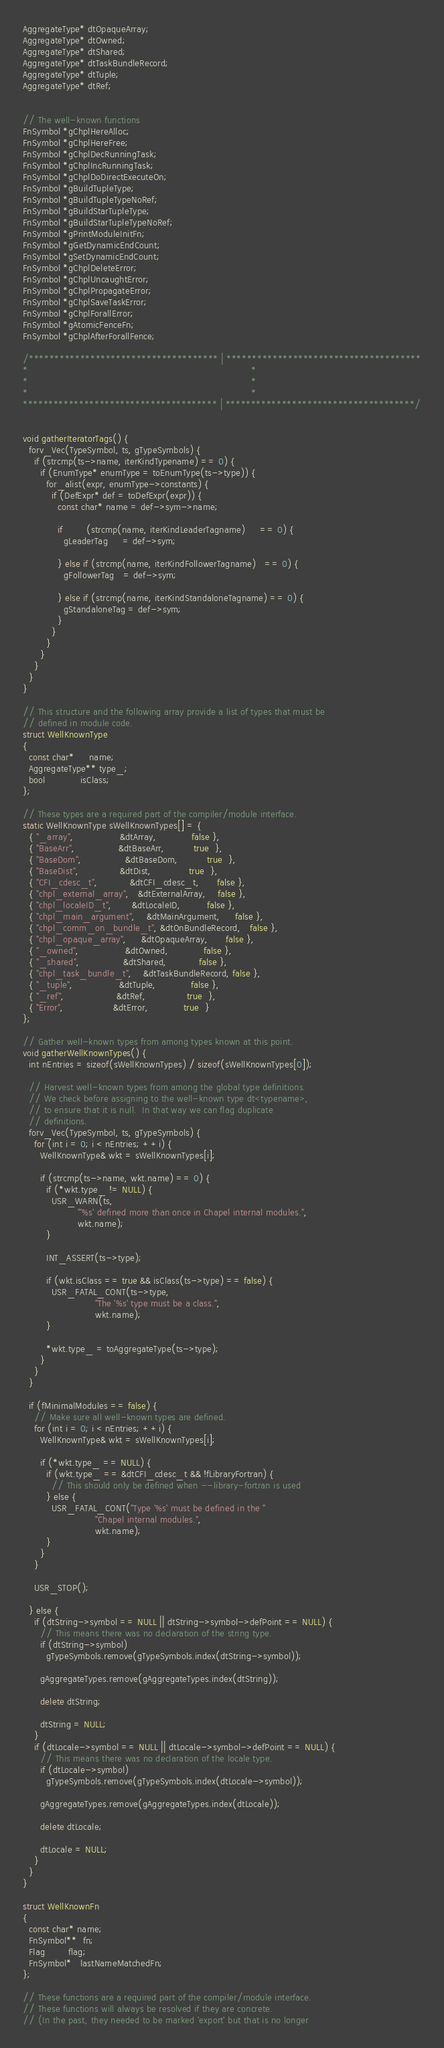<code> <loc_0><loc_0><loc_500><loc_500><_C++_>AggregateType* dtOpaqueArray;
AggregateType* dtOwned;
AggregateType* dtShared;
AggregateType* dtTaskBundleRecord;
AggregateType* dtTuple;
AggregateType* dtRef;


// The well-known functions
FnSymbol *gChplHereAlloc;
FnSymbol *gChplHereFree;
FnSymbol *gChplDecRunningTask;
FnSymbol *gChplIncRunningTask;
FnSymbol *gChplDoDirectExecuteOn;
FnSymbol *gBuildTupleType;
FnSymbol *gBuildTupleTypeNoRef;
FnSymbol *gBuildStarTupleType;
FnSymbol *gBuildStarTupleTypeNoRef;
FnSymbol *gPrintModuleInitFn;
FnSymbol *gGetDynamicEndCount;
FnSymbol *gSetDynamicEndCount;
FnSymbol *gChplDeleteError;
FnSymbol *gChplUncaughtError;
FnSymbol *gChplPropagateError;
FnSymbol *gChplSaveTaskError;
FnSymbol *gChplForallError;
FnSymbol *gAtomicFenceFn;
FnSymbol *gChplAfterForallFence;

/************************************* | **************************************
*                                                                             *
*                                                                             *
*                                                                             *
************************************** | *************************************/


void gatherIteratorTags() {
  forv_Vec(TypeSymbol, ts, gTypeSymbols) {
    if (strcmp(ts->name, iterKindTypename) == 0) {
      if (EnumType* enumType = toEnumType(ts->type)) {
        for_alist(expr, enumType->constants) {
          if (DefExpr* def = toDefExpr(expr)) {
            const char* name = def->sym->name;

            if        (strcmp(name, iterKindLeaderTagname)     == 0) {
              gLeaderTag     = def->sym;

            } else if (strcmp(name, iterKindFollowerTagname)   == 0) {
              gFollowerTag   = def->sym;

            } else if (strcmp(name, iterKindStandaloneTagname) == 0) {
              gStandaloneTag = def->sym;
            }
          }
        }
      }
    }
  }
}

// This structure and the following array provide a list of types that must be
// defined in module code.
struct WellKnownType
{
  const char*     name;
  AggregateType** type_;
  bool            isClass;
};

// These types are a required part of the compiler/module interface.
static WellKnownType sWellKnownTypes[] = {
  { "_array",                &dtArray,            false },
  { "BaseArr",               &dtBaseArr,          true  },
  { "BaseDom",               &dtBaseDom,          true  },
  { "BaseDist",              &dtDist,             true  },
  { "CFI_cdesc_t",           &dtCFI_cdesc_t,      false },
  { "chpl_external_array",   &dtExternalArray,    false },
  { "chpl_localeID_t",       &dtLocaleID,         false },
  { "chpl_main_argument",    &dtMainArgument,     false },
  { "chpl_comm_on_bundle_t", &dtOnBundleRecord,   false },
  { "chpl_opaque_array",     &dtOpaqueArray,      false },
  { "_owned",                &dtOwned,            false },
  { "_shared",               &dtShared,           false },
  { "chpl_task_bundle_t",    &dtTaskBundleRecord, false },
  { "_tuple",                &dtTuple,            false },
  { "_ref",                  &dtRef,              true  },
  { "Error",                 &dtError,            true  }
};

// Gather well-known types from among types known at this point.
void gatherWellKnownTypes() {
  int nEntries = sizeof(sWellKnownTypes) / sizeof(sWellKnownTypes[0]);

  // Harvest well-known types from among the global type definitions.
  // We check before assigning to the well-known type dt<typename>,
  // to ensure that it is null.  In that way we can flag duplicate
  // definitions.
  forv_Vec(TypeSymbol, ts, gTypeSymbols) {
    for (int i = 0; i < nEntries; ++i) {
      WellKnownType& wkt = sWellKnownTypes[i];

      if (strcmp(ts->name, wkt.name) == 0) {
        if (*wkt.type_ != NULL) {
          USR_WARN(ts,
                   "'%s' defined more than once in Chapel internal modules.",
                   wkt.name);
        }

        INT_ASSERT(ts->type);

        if (wkt.isClass == true && isClass(ts->type) == false) {
          USR_FATAL_CONT(ts->type,
                         "The '%s' type must be a class.",
                         wkt.name);
        }

        *wkt.type_ = toAggregateType(ts->type);
      }
    }
  }

  if (fMinimalModules == false) {
    // Make sure all well-known types are defined.
    for (int i = 0; i < nEntries; ++i) {
      WellKnownType& wkt = sWellKnownTypes[i];

      if (*wkt.type_ == NULL) {
        if (wkt.type_ == &dtCFI_cdesc_t && !fLibraryFortran) {
          // This should only be defined when --library-fortran is used
        } else {
          USR_FATAL_CONT("Type '%s' must be defined in the "
                         "Chapel internal modules.",
                         wkt.name);
        }
      }
    }

    USR_STOP();

  } else {
    if (dtString->symbol == NULL || dtString->symbol->defPoint == NULL) {
      // This means there was no declaration of the string type.
      if (dtString->symbol)
        gTypeSymbols.remove(gTypeSymbols.index(dtString->symbol));

      gAggregateTypes.remove(gAggregateTypes.index(dtString));

      delete dtString;

      dtString = NULL;
    }
    if (dtLocale->symbol == NULL || dtLocale->symbol->defPoint == NULL) {
      // This means there was no declaration of the locale type.
      if (dtLocale->symbol)
        gTypeSymbols.remove(gTypeSymbols.index(dtLocale->symbol));

      gAggregateTypes.remove(gAggregateTypes.index(dtLocale));

      delete dtLocale;

      dtLocale = NULL;
    }
  }
}

struct WellKnownFn
{
  const char* name;
  FnSymbol**  fn;
  Flag        flag;
  FnSymbol*   lastNameMatchedFn;
};

// These functions are a required part of the compiler/module interface.
// These functions will always be resolved if they are concrete.
// (In the past, they needed to be marked 'export' but that is no longer</code> 